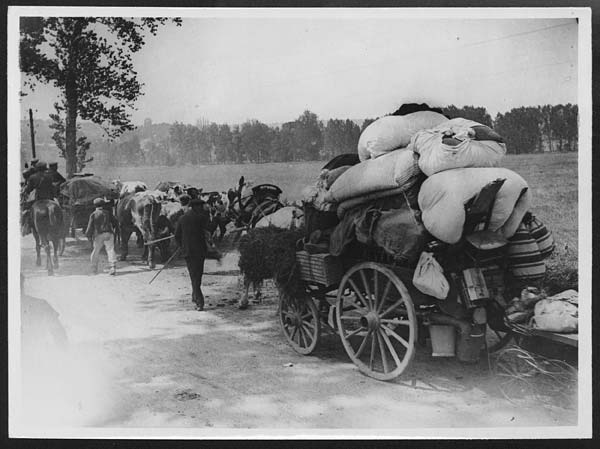Describe the objects in this image and their specific colors. I can see horse in gray and black tones, people in black, gray, and darkgray tones, cow in black, gray, darkgray, and lightgray tones, people in black, gray, darkgray, and lightgray tones, and horse in gray and black tones in this image. 